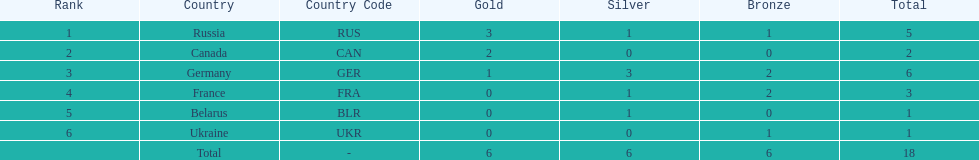How many silver medals did belarus win? 1. 